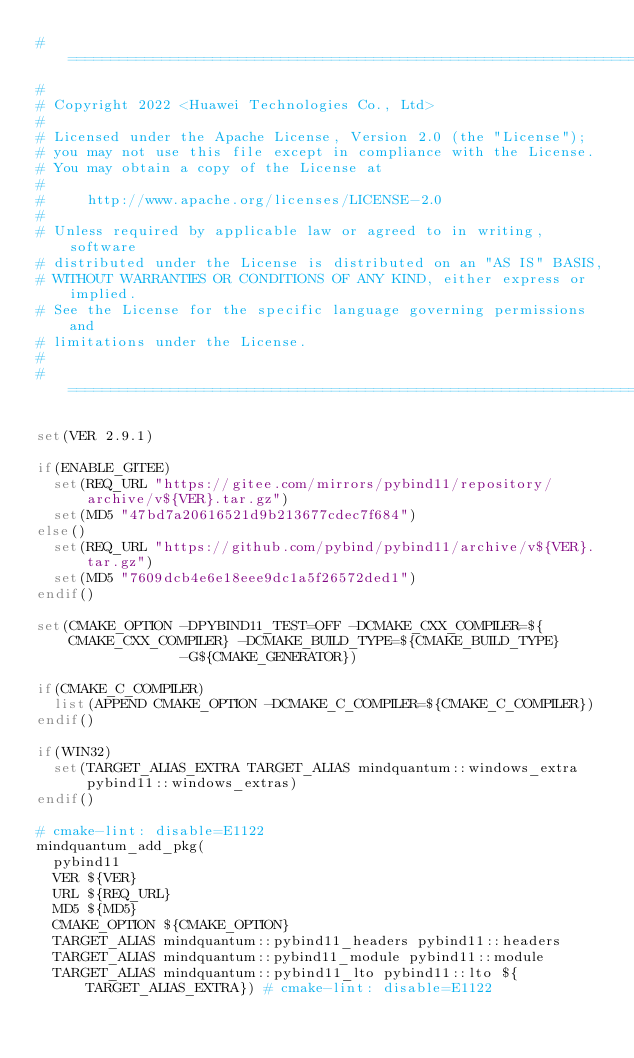<code> <loc_0><loc_0><loc_500><loc_500><_CMake_># ==============================================================================
#
# Copyright 2022 <Huawei Technologies Co., Ltd>
#
# Licensed under the Apache License, Version 2.0 (the "License");
# you may not use this file except in compliance with the License.
# You may obtain a copy of the License at
#
#     http://www.apache.org/licenses/LICENSE-2.0
#
# Unless required by applicable law or agreed to in writing, software
# distributed under the License is distributed on an "AS IS" BASIS,
# WITHOUT WARRANTIES OR CONDITIONS OF ANY KIND, either express or implied.
# See the License for the specific language governing permissions and
# limitations under the License.
#
# ==============================================================================

set(VER 2.9.1)

if(ENABLE_GITEE)
  set(REQ_URL "https://gitee.com/mirrors/pybind11/repository/archive/v${VER}.tar.gz")
  set(MD5 "47bd7a20616521d9b213677cdec7f684")
else()
  set(REQ_URL "https://github.com/pybind/pybind11/archive/v${VER}.tar.gz")
  set(MD5 "7609dcb4e6e18eee9dc1a5f26572ded1")
endif()

set(CMAKE_OPTION -DPYBIND11_TEST=OFF -DCMAKE_CXX_COMPILER=${CMAKE_CXX_COMPILER} -DCMAKE_BUILD_TYPE=${CMAKE_BUILD_TYPE}
                 -G${CMAKE_GENERATOR})

if(CMAKE_C_COMPILER)
  list(APPEND CMAKE_OPTION -DCMAKE_C_COMPILER=${CMAKE_C_COMPILER})
endif()

if(WIN32)
  set(TARGET_ALIAS_EXTRA TARGET_ALIAS mindquantum::windows_extra pybind11::windows_extras)
endif()

# cmake-lint: disable=E1122
mindquantum_add_pkg(
  pybind11
  VER ${VER}
  URL ${REQ_URL}
  MD5 ${MD5}
  CMAKE_OPTION ${CMAKE_OPTION}
  TARGET_ALIAS mindquantum::pybind11_headers pybind11::headers
  TARGET_ALIAS mindquantum::pybind11_module pybind11::module
  TARGET_ALIAS mindquantum::pybind11_lto pybind11::lto ${TARGET_ALIAS_EXTRA}) # cmake-lint: disable=E1122
</code> 